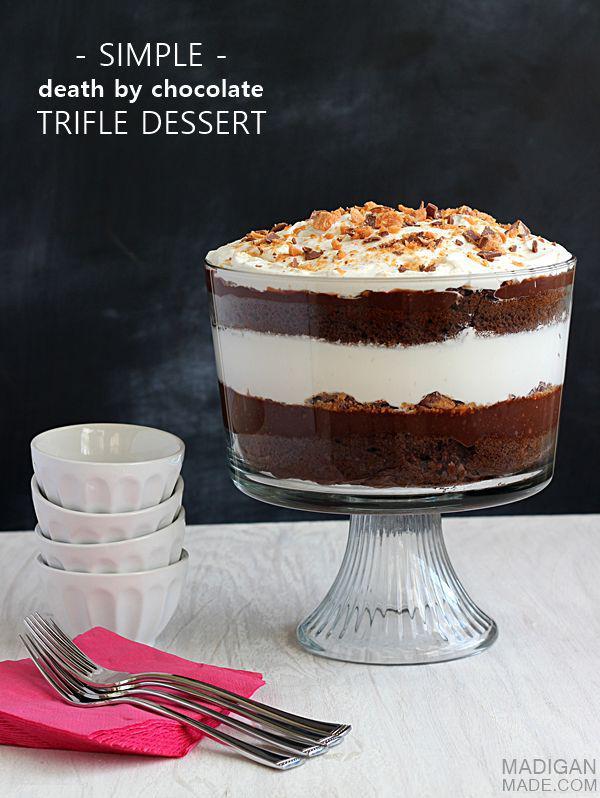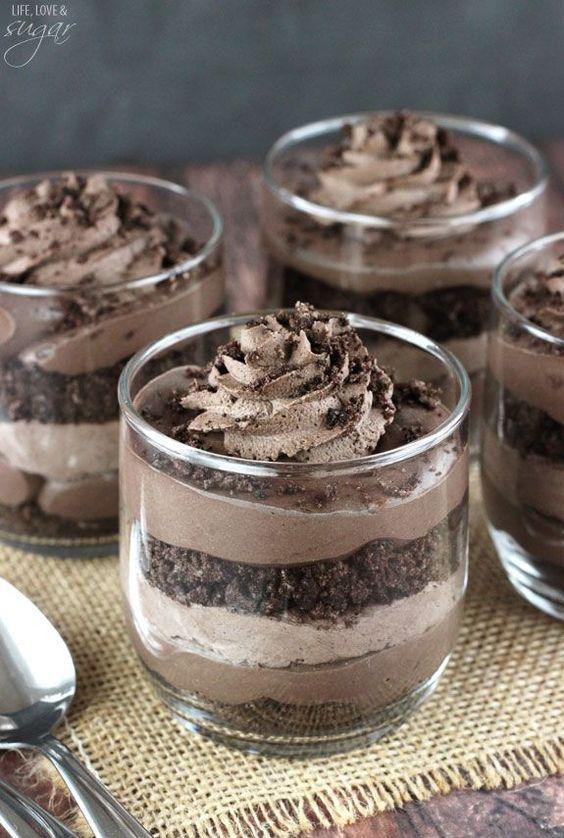The first image is the image on the left, the second image is the image on the right. For the images shown, is this caption "There are three cups of dessert in the image on the left." true? Answer yes or no. No. The first image is the image on the left, the second image is the image on the right. Examine the images to the left and right. Is the description "An image shows a group of layered desserts topped with brown whipped cream and sprinkles." accurate? Answer yes or no. Yes. 